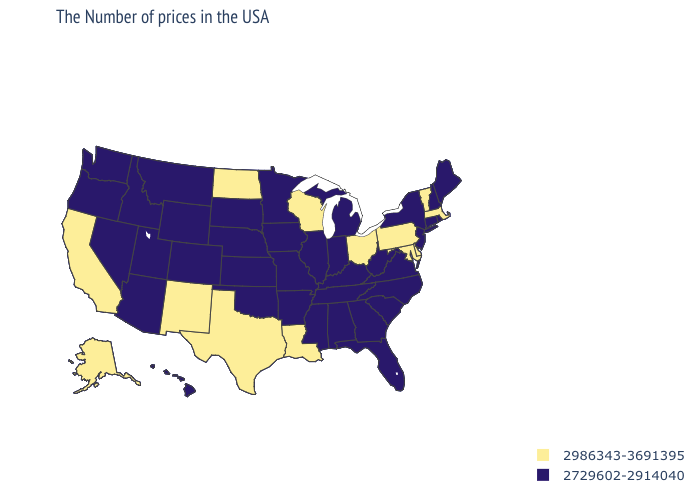Does the first symbol in the legend represent the smallest category?
Give a very brief answer. No. Does the map have missing data?
Concise answer only. No. Name the states that have a value in the range 2729602-2914040?
Give a very brief answer. Maine, Rhode Island, New Hampshire, Connecticut, New York, New Jersey, Virginia, North Carolina, South Carolina, West Virginia, Florida, Georgia, Michigan, Kentucky, Indiana, Alabama, Tennessee, Illinois, Mississippi, Missouri, Arkansas, Minnesota, Iowa, Kansas, Nebraska, Oklahoma, South Dakota, Wyoming, Colorado, Utah, Montana, Arizona, Idaho, Nevada, Washington, Oregon, Hawaii. What is the highest value in the Northeast ?
Give a very brief answer. 2986343-3691395. Name the states that have a value in the range 2729602-2914040?
Be succinct. Maine, Rhode Island, New Hampshire, Connecticut, New York, New Jersey, Virginia, North Carolina, South Carolina, West Virginia, Florida, Georgia, Michigan, Kentucky, Indiana, Alabama, Tennessee, Illinois, Mississippi, Missouri, Arkansas, Minnesota, Iowa, Kansas, Nebraska, Oklahoma, South Dakota, Wyoming, Colorado, Utah, Montana, Arizona, Idaho, Nevada, Washington, Oregon, Hawaii. Does Indiana have the same value as Mississippi?
Keep it brief. Yes. Among the states that border Montana , does North Dakota have the lowest value?
Give a very brief answer. No. Name the states that have a value in the range 2986343-3691395?
Short answer required. Massachusetts, Vermont, Delaware, Maryland, Pennsylvania, Ohio, Wisconsin, Louisiana, Texas, North Dakota, New Mexico, California, Alaska. Name the states that have a value in the range 2729602-2914040?
Be succinct. Maine, Rhode Island, New Hampshire, Connecticut, New York, New Jersey, Virginia, North Carolina, South Carolina, West Virginia, Florida, Georgia, Michigan, Kentucky, Indiana, Alabama, Tennessee, Illinois, Mississippi, Missouri, Arkansas, Minnesota, Iowa, Kansas, Nebraska, Oklahoma, South Dakota, Wyoming, Colorado, Utah, Montana, Arizona, Idaho, Nevada, Washington, Oregon, Hawaii. Does the first symbol in the legend represent the smallest category?
Concise answer only. No. Does the first symbol in the legend represent the smallest category?
Give a very brief answer. No. Among the states that border Nevada , which have the lowest value?
Concise answer only. Utah, Arizona, Idaho, Oregon. Which states have the highest value in the USA?
Be succinct. Massachusetts, Vermont, Delaware, Maryland, Pennsylvania, Ohio, Wisconsin, Louisiana, Texas, North Dakota, New Mexico, California, Alaska. Which states have the highest value in the USA?
Write a very short answer. Massachusetts, Vermont, Delaware, Maryland, Pennsylvania, Ohio, Wisconsin, Louisiana, Texas, North Dakota, New Mexico, California, Alaska. 